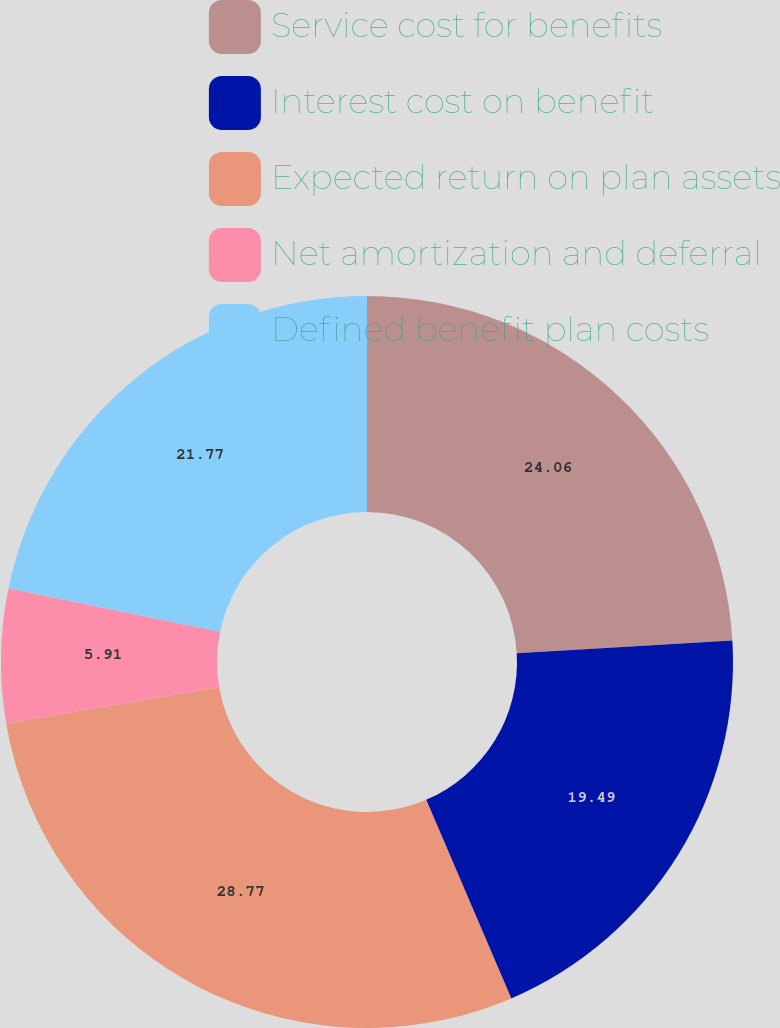Convert chart. <chart><loc_0><loc_0><loc_500><loc_500><pie_chart><fcel>Service cost for benefits<fcel>Interest cost on benefit<fcel>Expected return on plan assets<fcel>Net amortization and deferral<fcel>Defined benefit plan costs<nl><fcel>24.06%<fcel>19.49%<fcel>28.76%<fcel>5.91%<fcel>21.77%<nl></chart> 